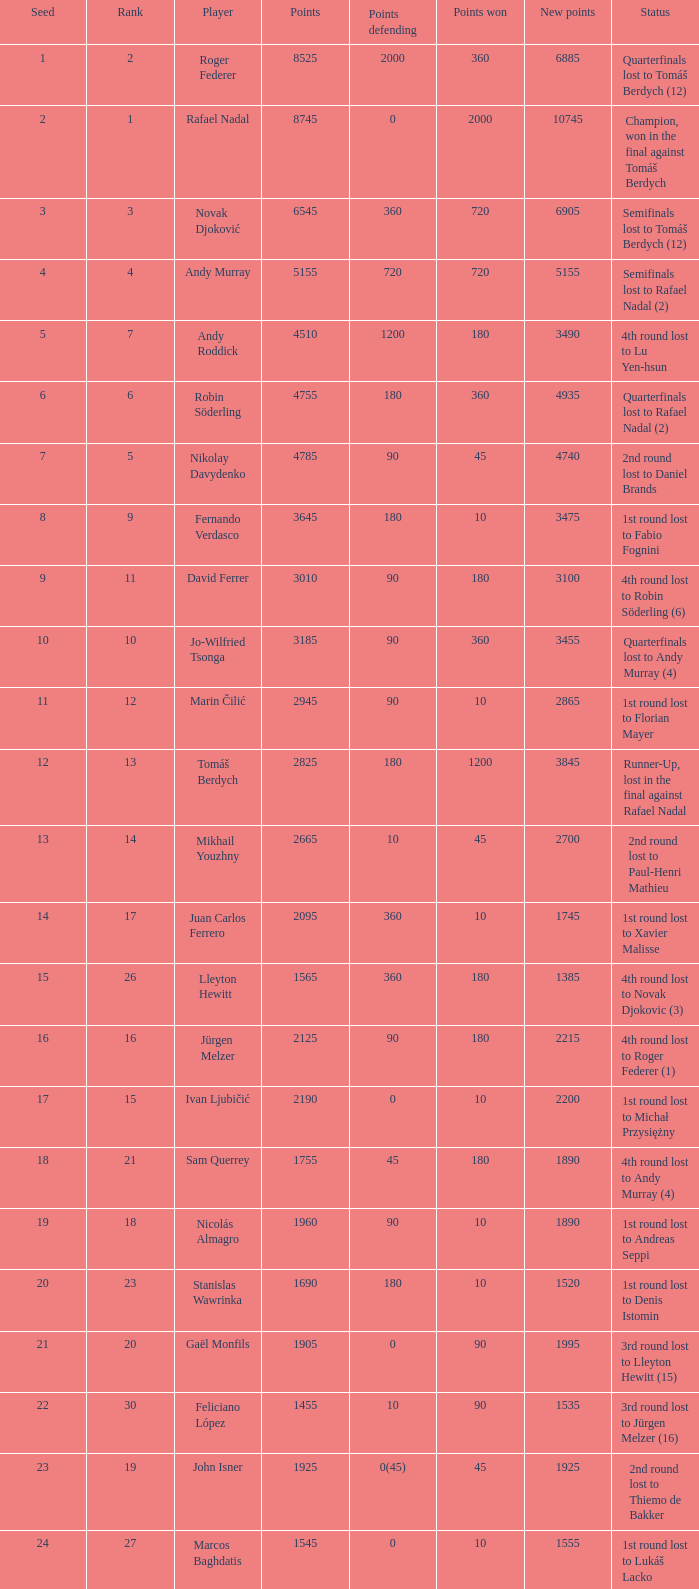Specify the count of points protecting for 1075 1.0. 